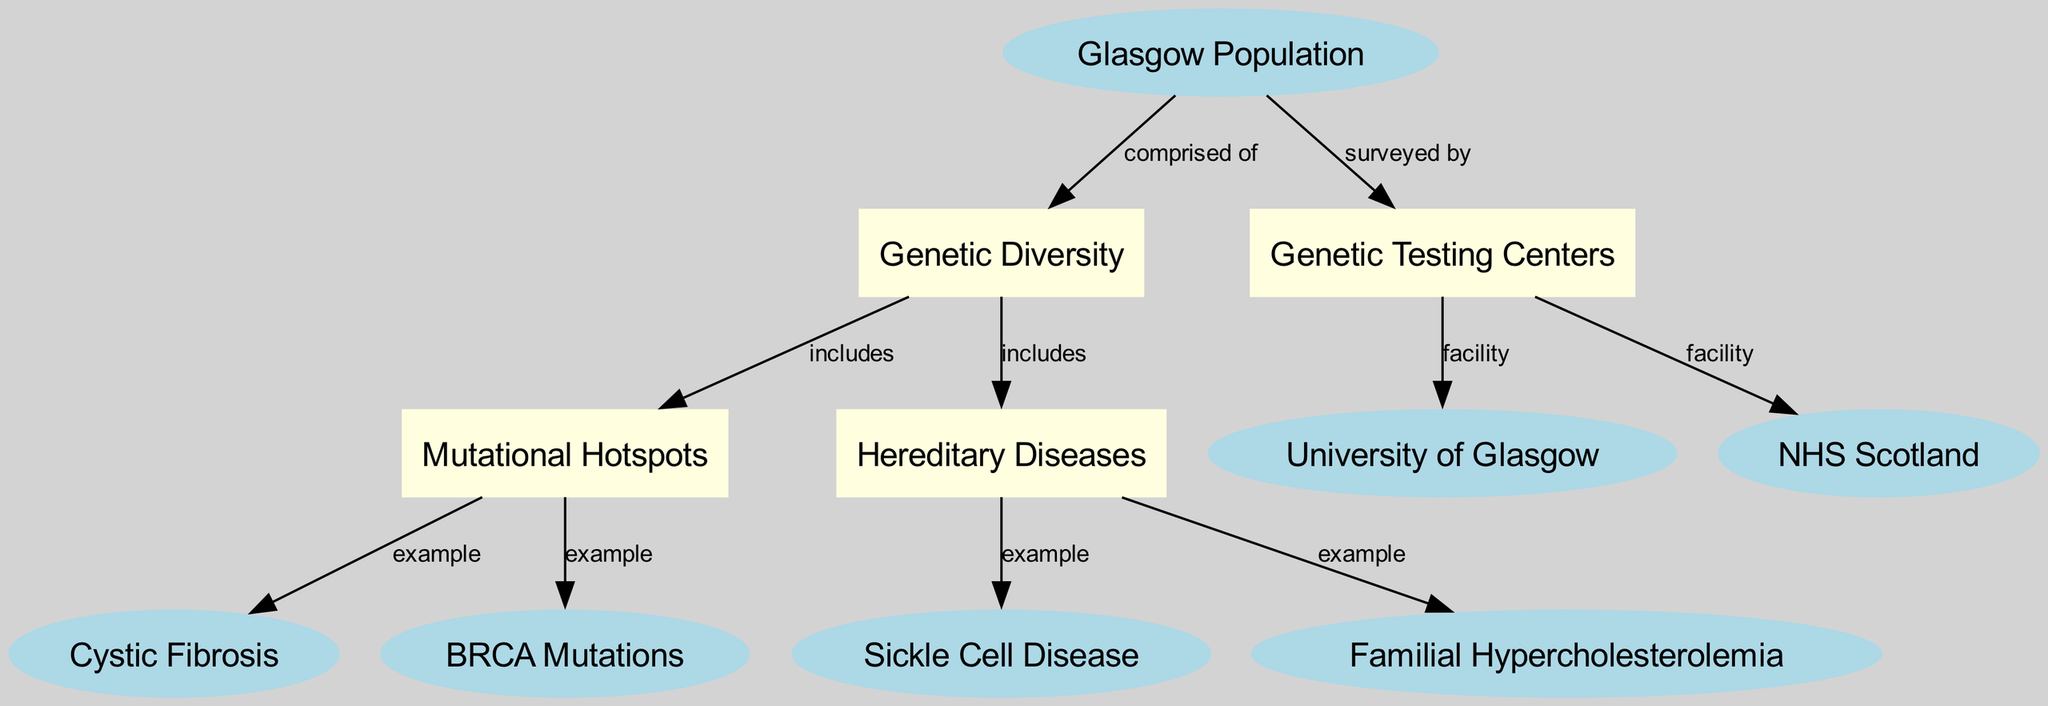What is the total number of nodes in the diagram? The diagram lists 11 nodes, which include various elements related to Glasgow's genetic landscape such as the population, genetic diversity, mutational hotspots, hereditary diseases, specific disease examples, and facilities. By counting all listed nodes, I confirm the total is 11.
Answer: 11 Which node represents the example of a hereditary disease? According to the diagram, Sickle Cell Disease and Familial Hypercholesterolemia are instances of hereditary diseases linked to the main category "Hereditary Diseases." Therefore, the answer regarding a specific example is identified clearly.
Answer: Sickle Cell Disease How many edges connect the "Glasgow Population" to other nodes? The "Glasgow Population" node connects to three distinct nodes: "Genetic Diversity," "Genetic Testing Centers," and "Mutational Hotspots." By examining the outgoing edges from this node, I tally three connections.
Answer: 3 Which entity is listed as a facility for genetic testing? The diagram indicates two entities are facilities for genetic testing: the "University of Glasgow" and "NHS Scotland." Identifying these nodes leads to the answer that they both serve this function.
Answer: University of Glasgow What is a direct example of a mutational hotspot mentioned? The diagram highlights two specific examples of mutational hotspots: Cystic Fibrosis and BRCA Mutations. As I review the connections from "Mutational Hotspots," I can pinpoint these as direct examples.
Answer: Cystic Fibrosis What disease is an example of the hereditary condition categorized under "Hereditary Diseases"? "Familial Hypercholesterolemia" is specifically listed as an example of a hereditary disease in the diagram. Tracing the relationships leads directly to this conclusion as it is explicitly categorized.
Answer: Familial Hypercholesterolemia What is the relationship between "Genetic Diversity" and "Mutational Hotspots"? The diagram indicates that "Genetic Diversity" includes "Mutational Hotspots," establishing a direct relationship between the two where one falls under the category of the other. This can be interpreted readily from the edges connecting these entities.
Answer: includes Which node is described as "comprised of" the Glasgow population? The node "Glasgow Population" itself is the central theme in the diagram's structure, leading to the understanding that it serves as the baseline for assessing both genetic diversity and other factors linked to this population.
Answer: Genetic Diversity 